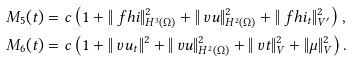Convert formula to latex. <formula><loc_0><loc_0><loc_500><loc_500>M _ { 5 } ( t ) & = c \left ( 1 + \| \ f h i \| _ { H ^ { 3 } ( \Omega ) } ^ { 2 } + \| \ v u \| _ { H ^ { 2 } ( \Omega ) } ^ { 2 } + \| \ f h i _ { t } \| _ { V ^ { \prime } } ^ { 2 } \right ) , \\ M _ { 6 } ( t ) & = c \left ( 1 + \| \ v u _ { t } \| ^ { 2 } + \| \ v u \| _ { H ^ { 2 } ( \Omega ) } ^ { 2 } + \| \ v t \| _ { V } ^ { 2 } + \| \mu \| _ { V } ^ { 2 } \right ) .</formula> 